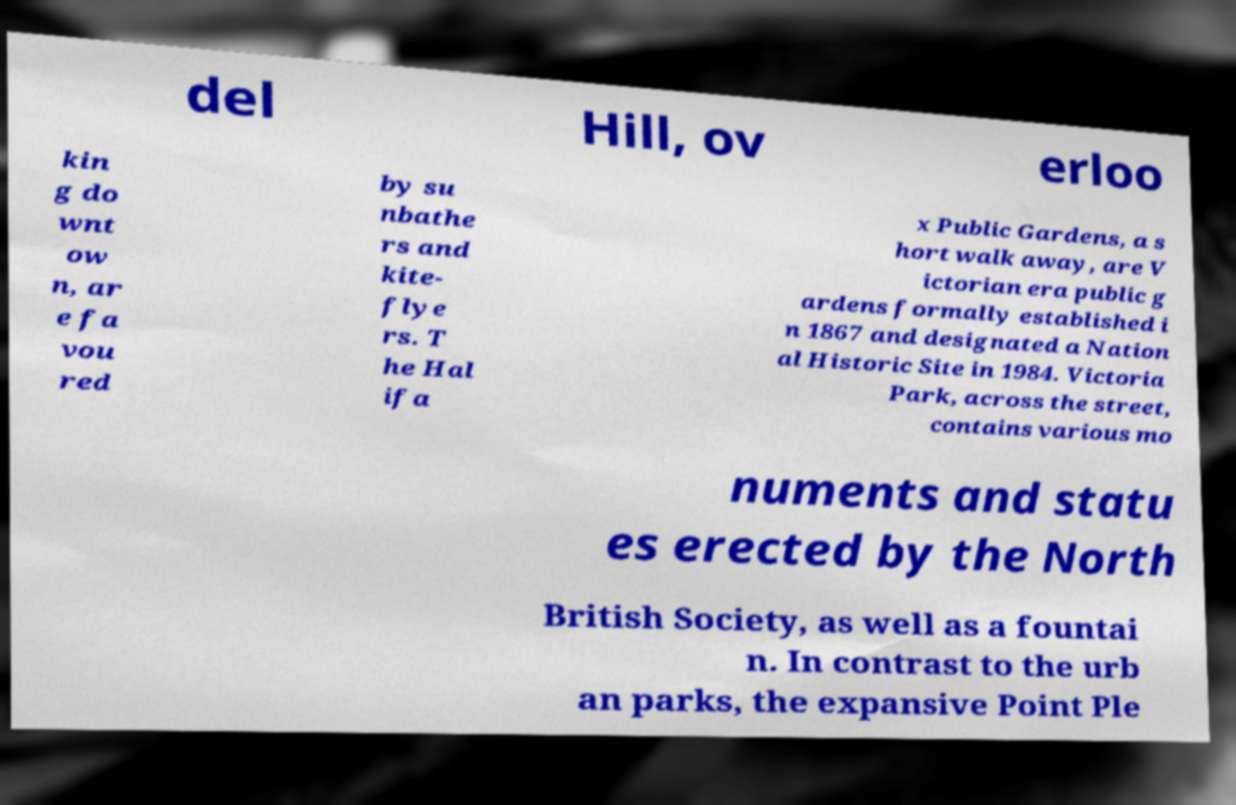Could you assist in decoding the text presented in this image and type it out clearly? del Hill, ov erloo kin g do wnt ow n, ar e fa vou red by su nbathe rs and kite- flye rs. T he Hal ifa x Public Gardens, a s hort walk away, are V ictorian era public g ardens formally established i n 1867 and designated a Nation al Historic Site in 1984. Victoria Park, across the street, contains various mo numents and statu es erected by the North British Society, as well as a fountai n. In contrast to the urb an parks, the expansive Point Ple 